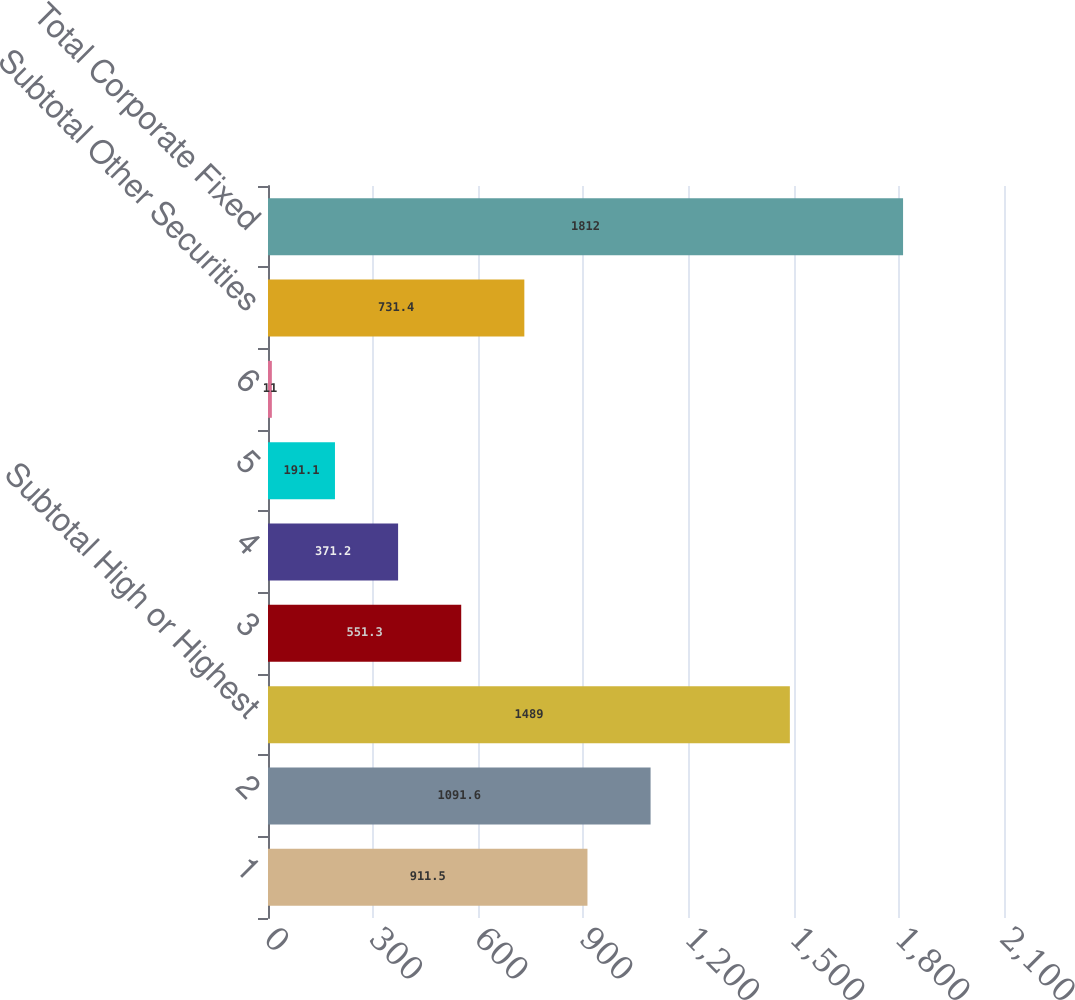<chart> <loc_0><loc_0><loc_500><loc_500><bar_chart><fcel>1<fcel>2<fcel>Subtotal High or Highest<fcel>3<fcel>4<fcel>5<fcel>6<fcel>Subtotal Other Securities<fcel>Total Corporate Fixed<nl><fcel>911.5<fcel>1091.6<fcel>1489<fcel>551.3<fcel>371.2<fcel>191.1<fcel>11<fcel>731.4<fcel>1812<nl></chart> 